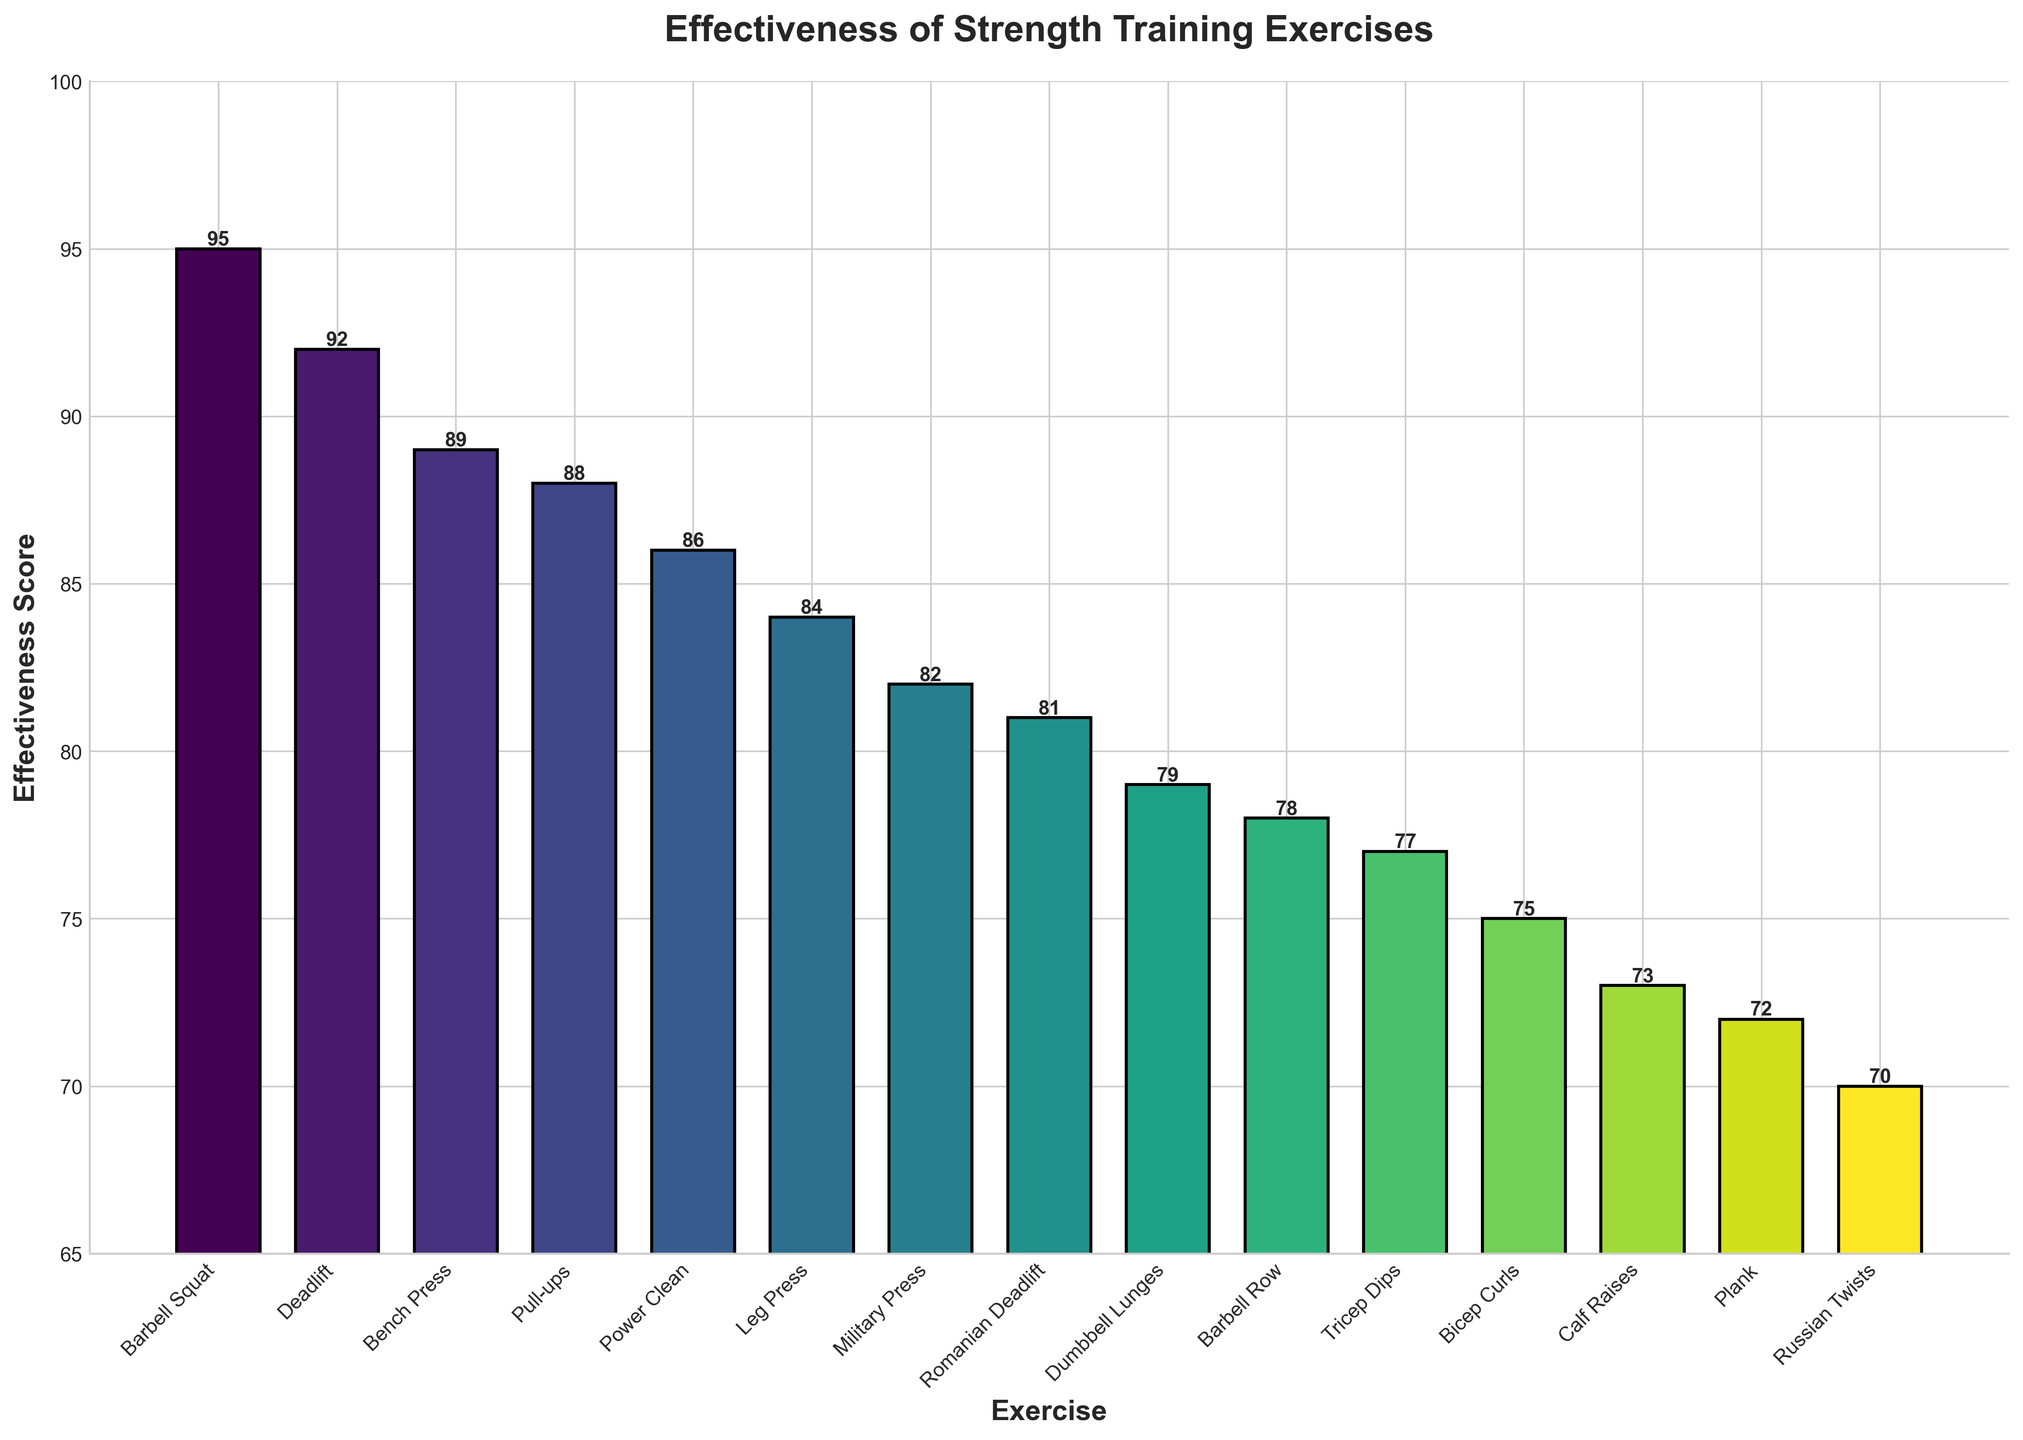Which exercise has the highest effectiveness score? The highest bar represents the exercise with the highest effectiveness score. The barbell squat has the highest bar with a score of 95.
Answer: Barbell Squat Which exercise targets the lower back and what is its effectiveness score? Look for the exercise labeled "Lower Back" and read its corresponding effectiveness score. The deadlift targets the lower back and has an effectiveness score of 92.
Answer: Deadlift, 92 Compare the effectiveness scores of bench press and military press. Locate the bars for bench press and military press and compare their heights and annotations. The bench press has a score of 89, while the military press has a score of 82.
Answer: Bench press is higher by 7 Which exercise has the lowest effectiveness score and what muscle group does it target? Find the bar with the lowest height and read its label and effectiveness score. Russian twists have the lowest score of 70 and target the obliques.
Answer: Russian Twists, Obliques What is the average effectiveness score of the top three exercises? Identify the top three exercises by effectiveness score: Barbell Squat (95), Deadlift (92), and Bench Press (89). Sum these scores: 95 + 92 + 89 = 276. Then divide by 3 to get the average: 276 / 3 = 92.
Answer: 92 What is the total effectiveness score for exercises that target the quadriceps? Find the bars labeled Quadriceps: Barbell Squat (95) and Leg Press (84). Sum these scores: 95 + 84 = 179.
Answer: 179 Which exercise targeting the hamstrings has the highest effectiveness score, and what is the score? Identify the exercise targeting the hamstrings and read its effectiveness score. Romanian Deadlift targets the hamstrings with a score of 81.
Answer: Romanian Deadlift, 81 How does the effectiveness score of calf raises compare to the effectiveness score of plank? Find the bars for calf raises and plank and compare their heights and annotations. Calf raises have a score of 73, while plank has a score of 72.
Answer: Calf Raises is higher by 1 What is the difference in the effectiveness score between dumbbell lunges and barbell row? Locate the bars for dumbbell lunges and barbell row and subtract their scores: 79 (Dumbbell Lunges) - 78 (Barbell Row) = 1.
Answer: 1 Which three exercises in the data target the shoulders, core, and biceps, and what are their effectiveness scores? Find the bars labeled Shoulders, Core, and Biceps and read their effectiveness scores: Military Press (Shoulders, 82), Plank (Core, 72), Bicep Curls (Biceps, 75).
Answer: Military Press: 82, Plank: 72, Bicep Curls: 75 